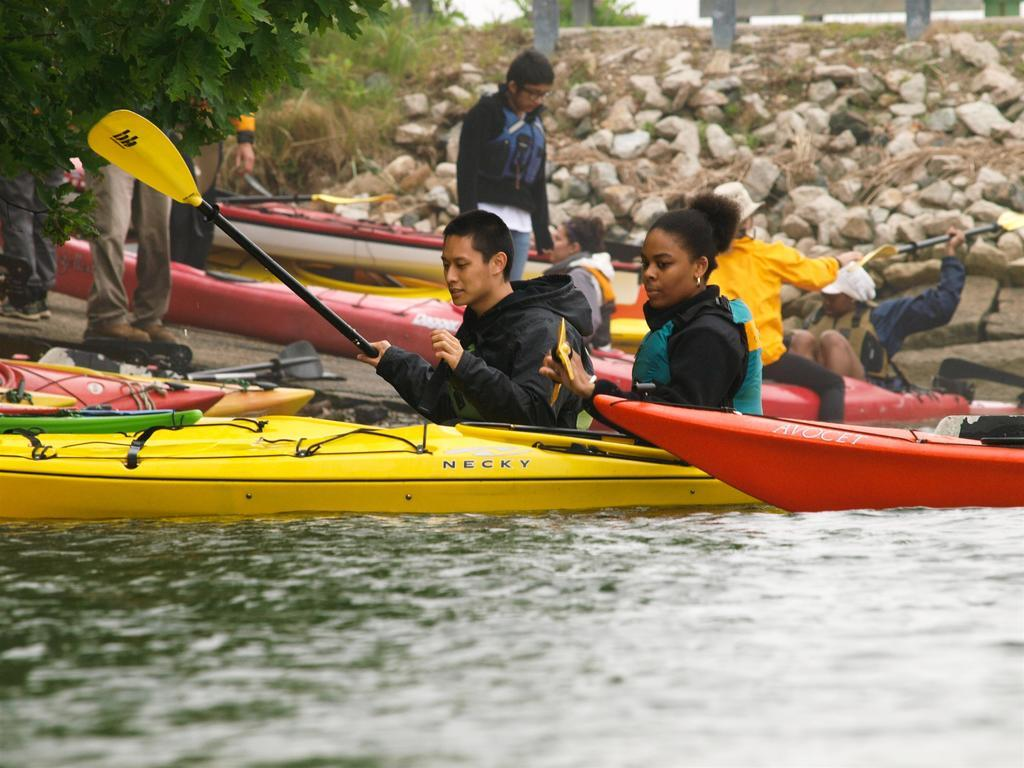What activity are the people in the image engaged in? There are people rowing a boat in the image. What can be seen in the background of the image? There are trees and rocks in the background of the image. Are there any other boats visible in the image? Yes, there are other boats in the background of the image. What is visible at the bottom of the image? There is water visible at the bottom of the image. What type of wine is being served on the boat in the image? There is no wine present in the image; it features people rowing a boat with no visible food or drink. 